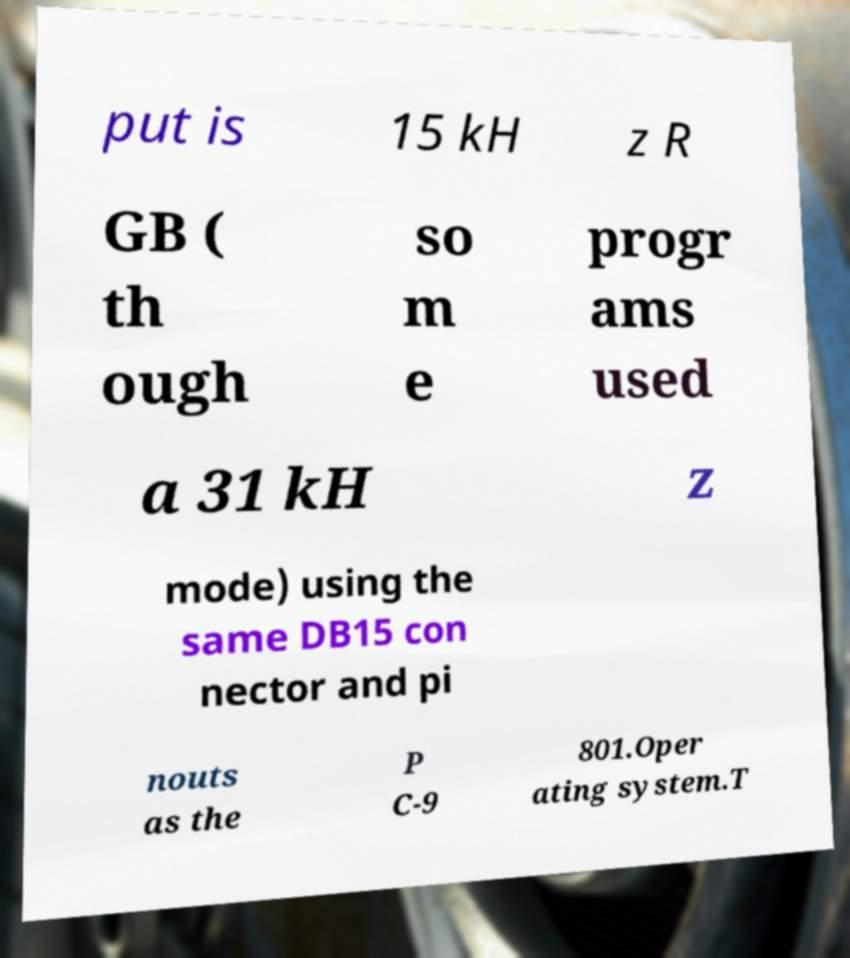Please identify and transcribe the text found in this image. put is 15 kH z R GB ( th ough so m e progr ams used a 31 kH z mode) using the same DB15 con nector and pi nouts as the P C-9 801.Oper ating system.T 